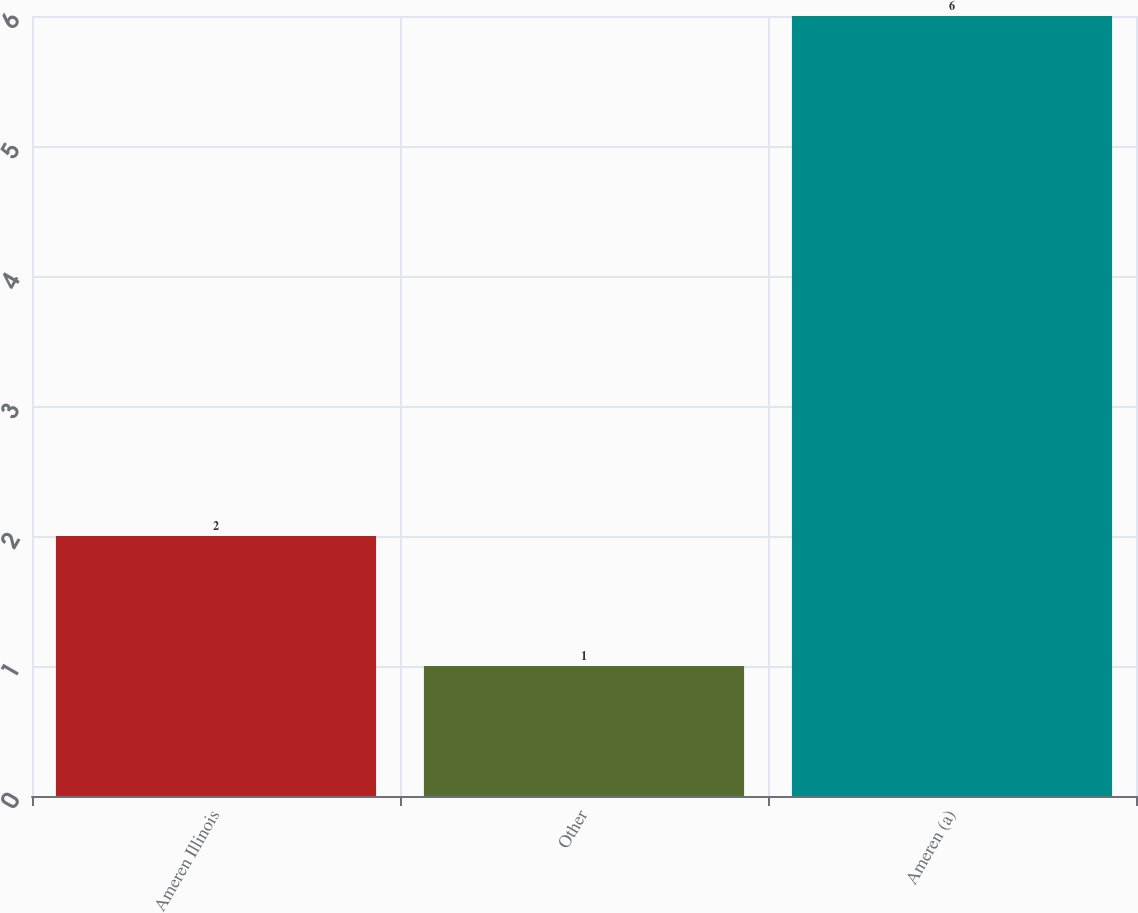Convert chart to OTSL. <chart><loc_0><loc_0><loc_500><loc_500><bar_chart><fcel>Ameren Illinois<fcel>Other<fcel>Ameren (a)<nl><fcel>2<fcel>1<fcel>6<nl></chart> 